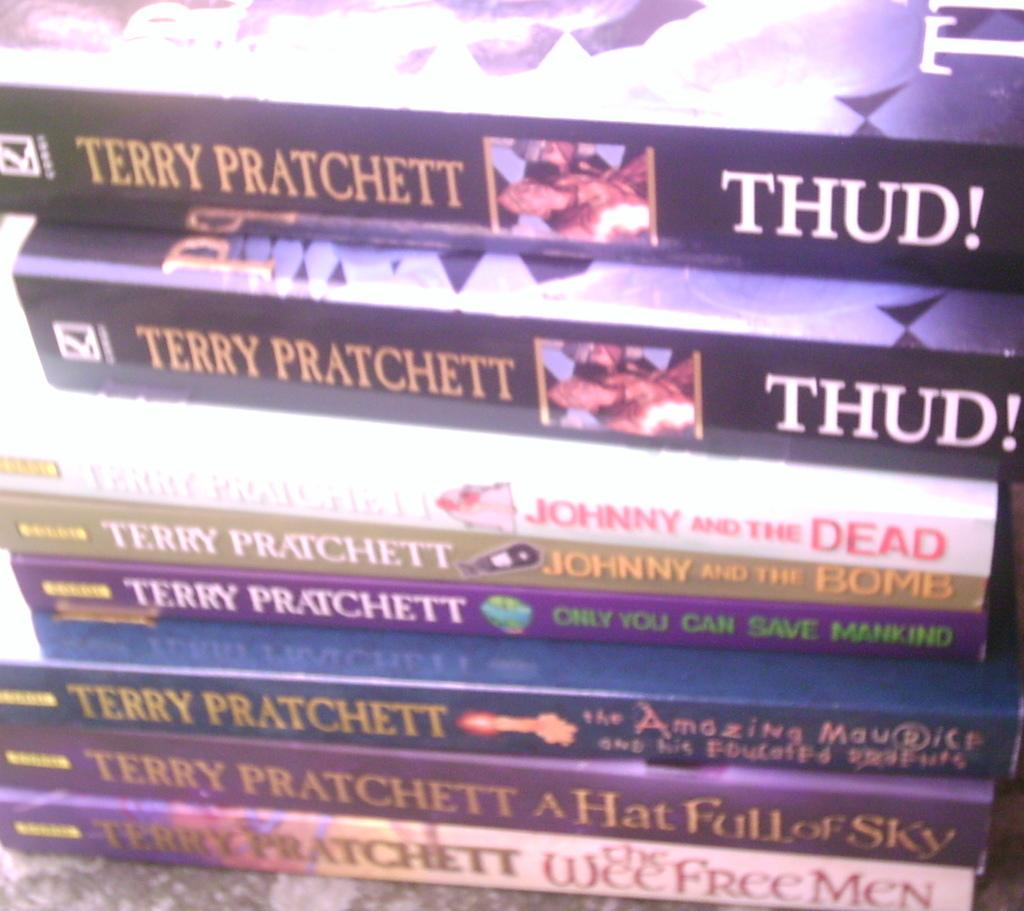Provide a one-sentence caption for the provided image. About 7 or more book series of Terry Pratchett stacked on top of each other. 